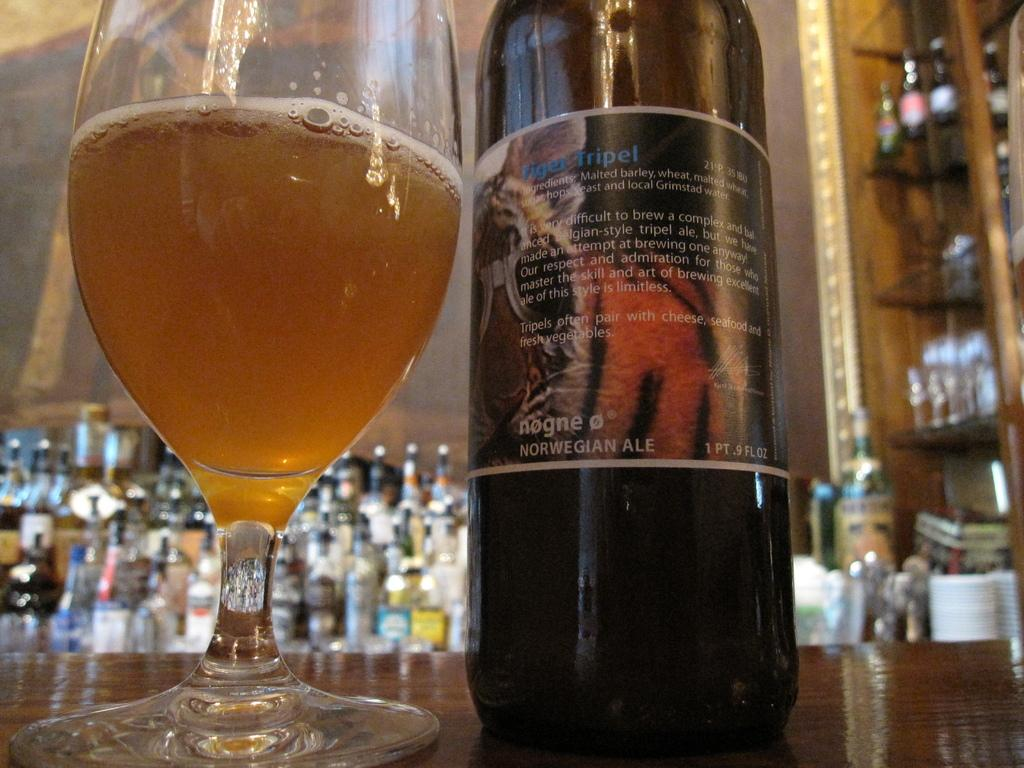<image>
Offer a succinct explanation of the picture presented. A bottle of Tiger Tripel is poured into the glass next to it. 